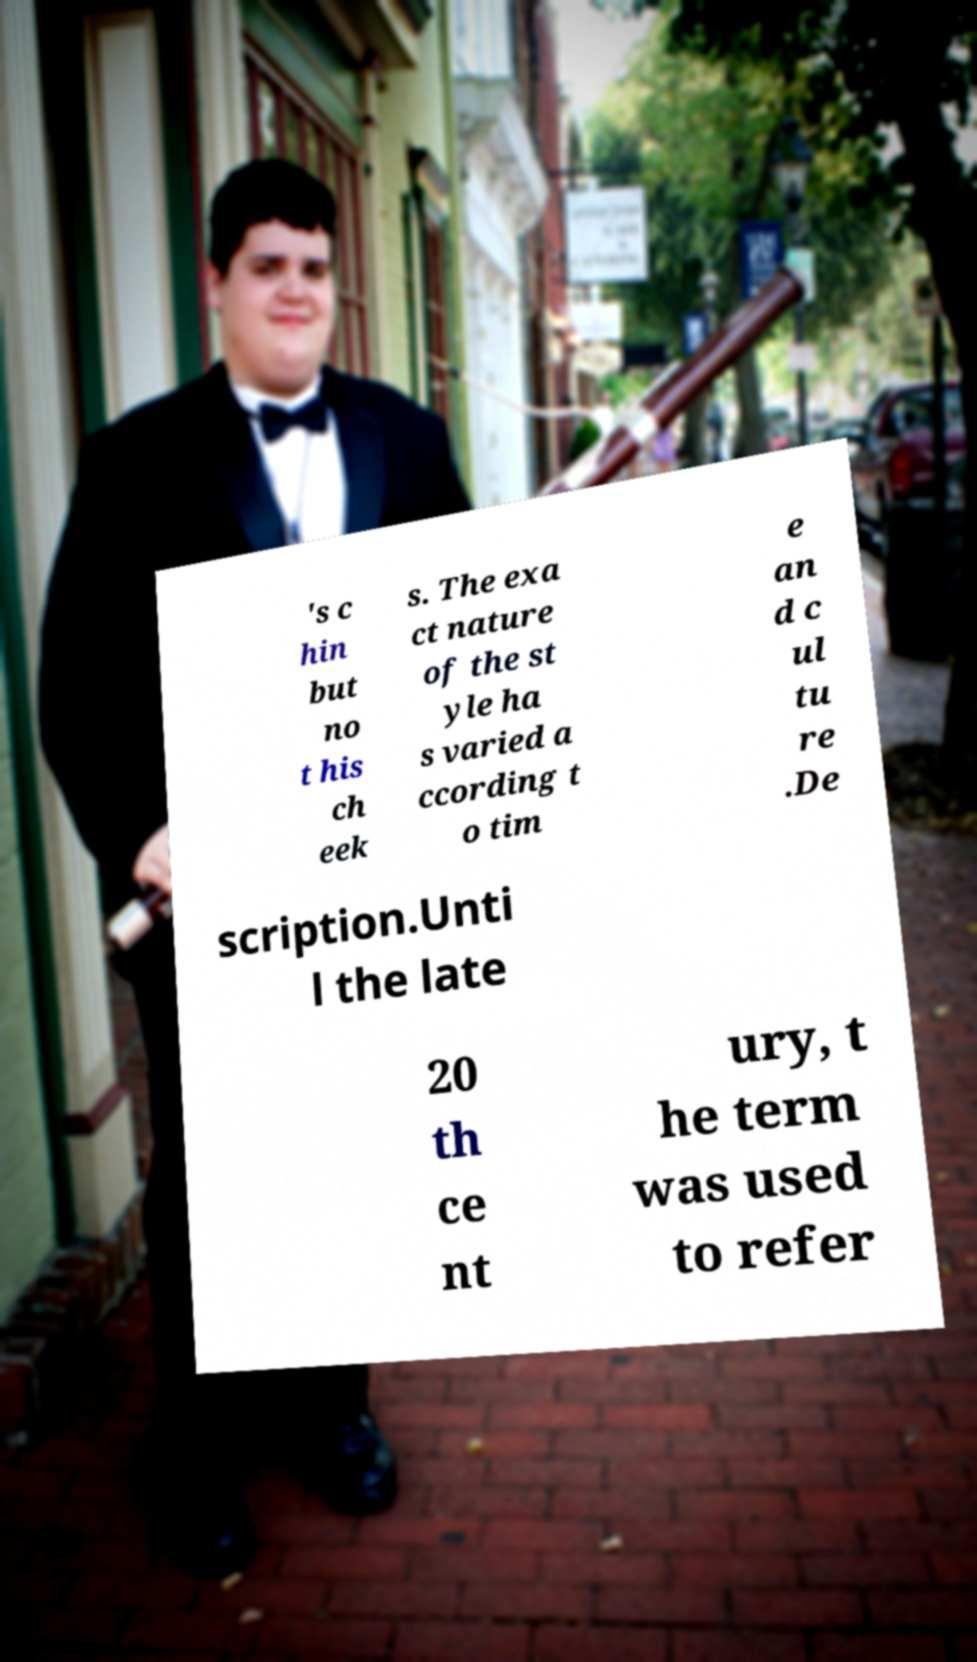Can you accurately transcribe the text from the provided image for me? 's c hin but no t his ch eek s. The exa ct nature of the st yle ha s varied a ccording t o tim e an d c ul tu re .De scription.Unti l the late 20 th ce nt ury, t he term was used to refer 